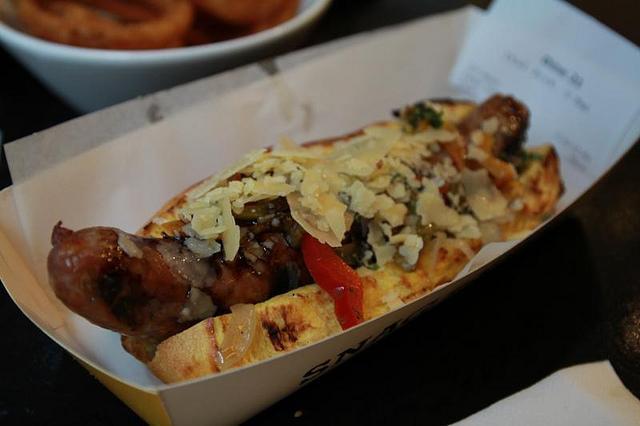How many bowls are there?
Give a very brief answer. 2. 